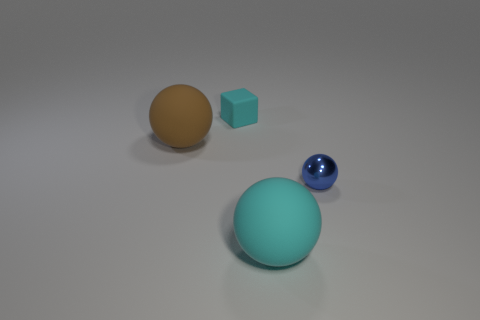What material is the object that is behind the small shiny thing and to the right of the big brown rubber ball?
Ensure brevity in your answer.  Rubber. There is a object that is right of the cyan matte block and on the left side of the blue metal ball; what color is it?
Ensure brevity in your answer.  Cyan. Is there anything else that is the same color as the shiny ball?
Your answer should be compact. No. There is a cyan matte object that is in front of the big matte thing to the left of the cyan thing in front of the small rubber cube; what shape is it?
Keep it short and to the point. Sphere. What color is the small metal object that is the same shape as the brown matte object?
Give a very brief answer. Blue. What is the color of the small thing that is right of the small thing that is to the left of the large cyan matte sphere?
Make the answer very short. Blue. There is a brown thing that is the same shape as the blue thing; what is its size?
Make the answer very short. Large. How many tiny blue balls have the same material as the brown ball?
Your answer should be compact. 0. How many brown matte balls are to the left of the large rubber object behind the big cyan object?
Ensure brevity in your answer.  0. Are there any large spheres behind the blue sphere?
Offer a terse response. Yes. 